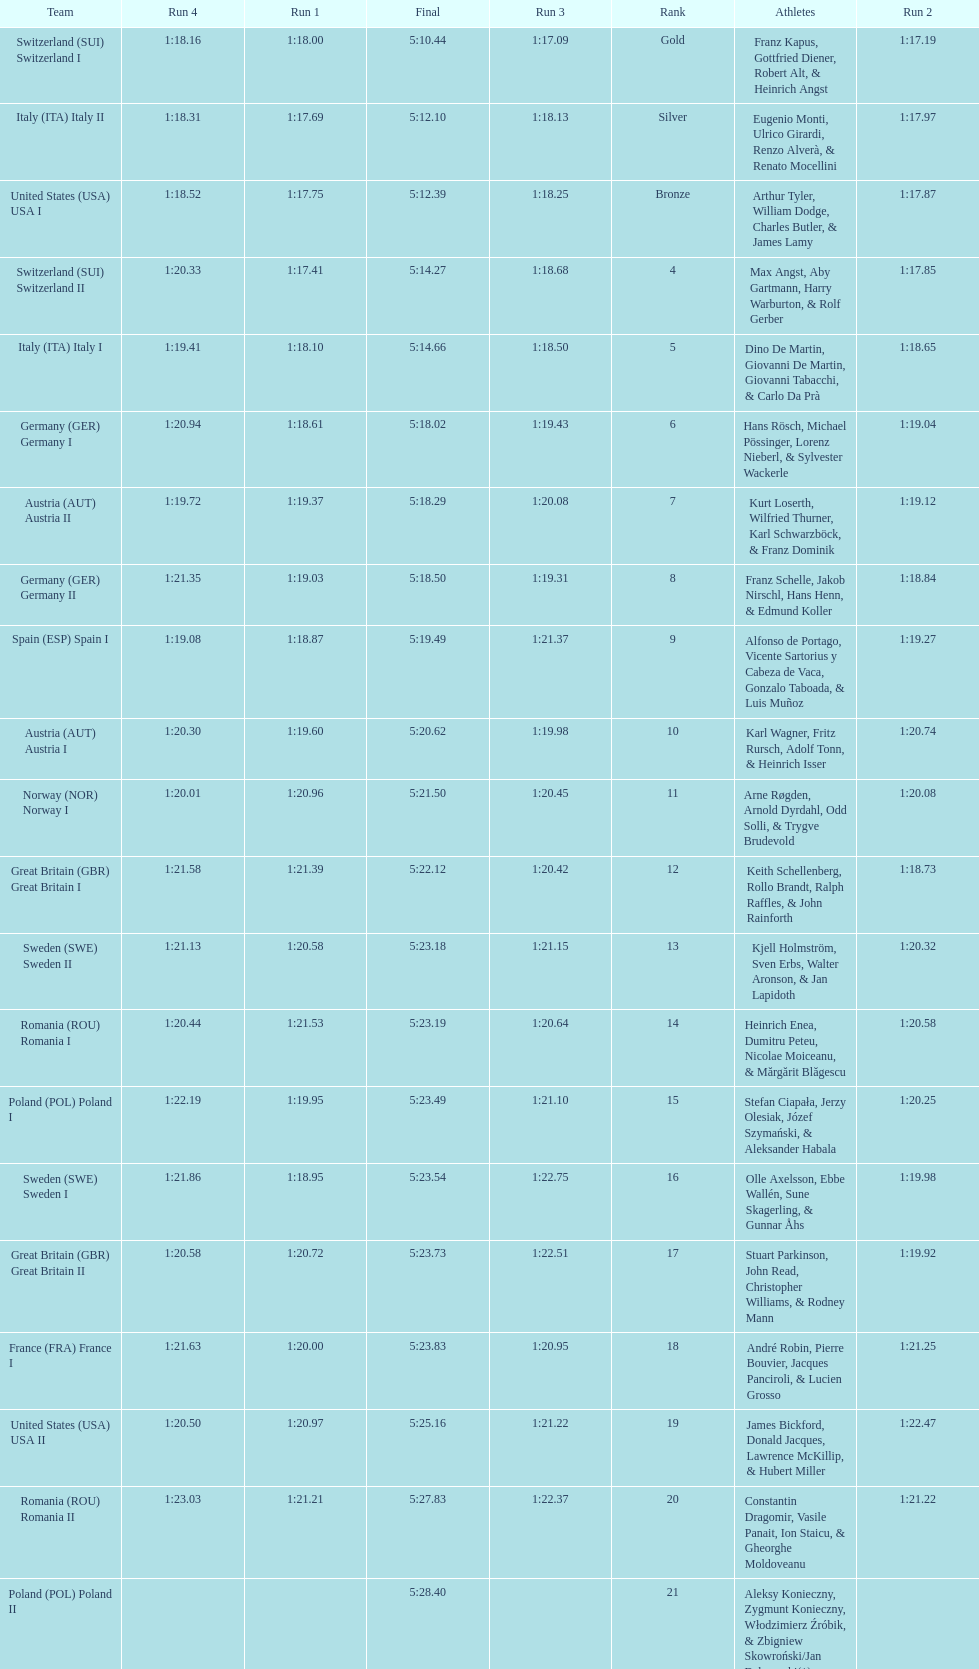Who placed the highest, italy or germany? Italy. 